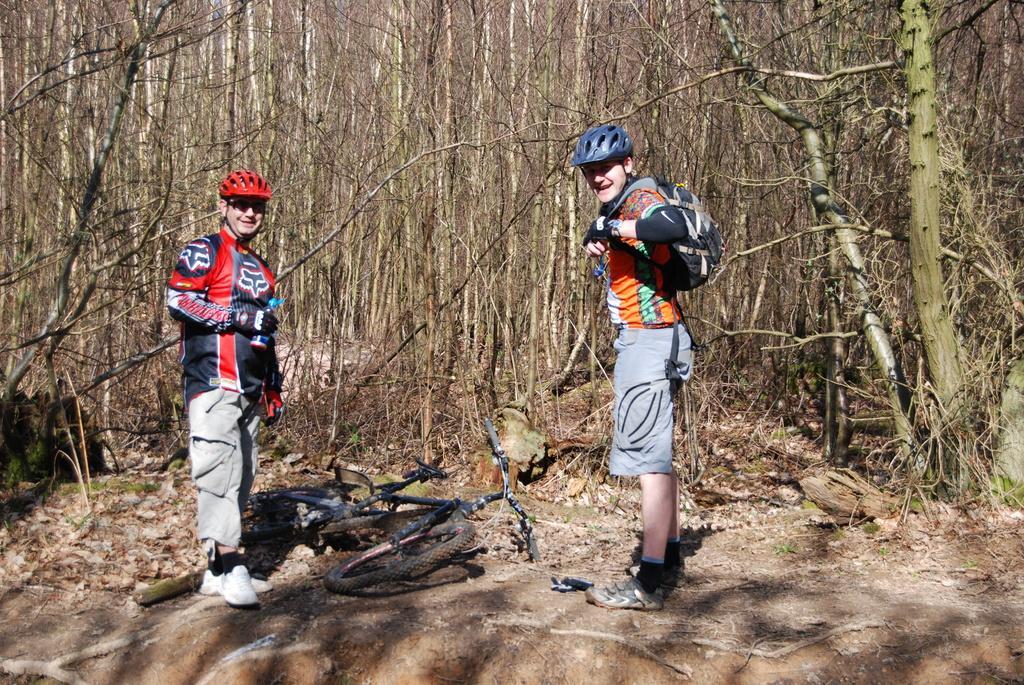How would you summarize this image in a sentence or two? On the left side, there is a person wearing a red color helmet, holding a bottle, smiling and standing. Beside him, there is a bicycle fallen on the ground. On the right side, there is another person wearing a violet color helmet, smiling and standing. In the background, there are trees and grass on the ground. 